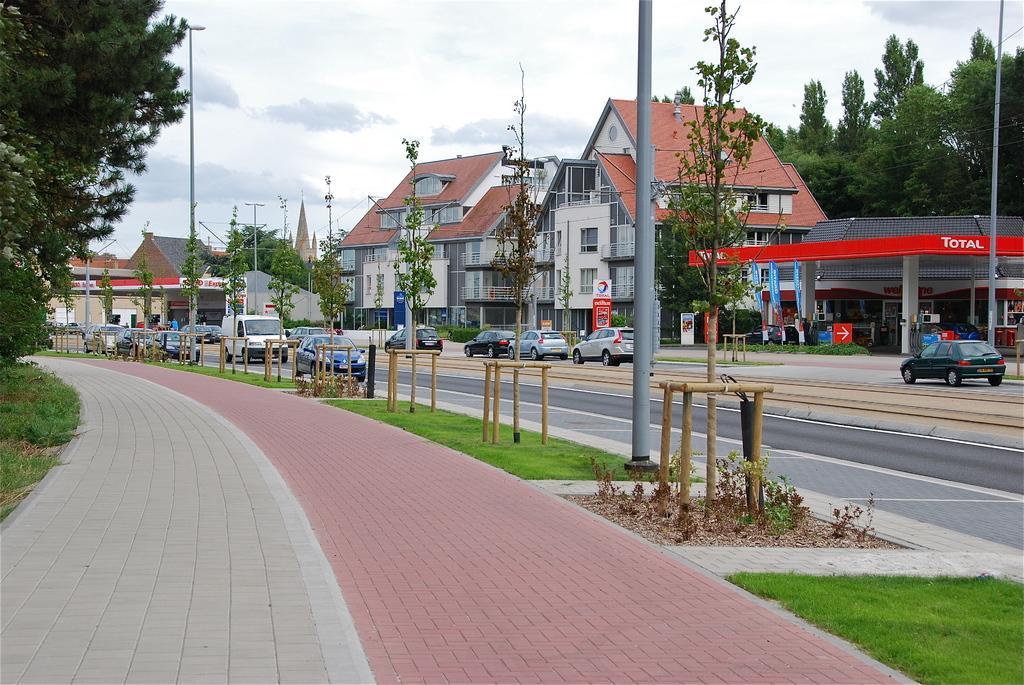Describe this image in one or two sentences. In the foreground of this image, there is pavement and on the left, there are trees. On the right, there is a vehicle moving on the road, a pole, shelter, few flag like objects and the trees. In the middle, there are buildings, vehicles moving on the road, trees, few banners and the wooden poles on the grass land. At the top, there is the sky and the cloud. 